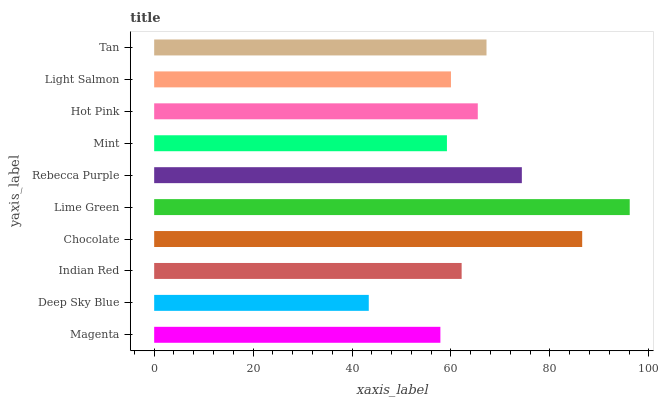Is Deep Sky Blue the minimum?
Answer yes or no. Yes. Is Lime Green the maximum?
Answer yes or no. Yes. Is Indian Red the minimum?
Answer yes or no. No. Is Indian Red the maximum?
Answer yes or no. No. Is Indian Red greater than Deep Sky Blue?
Answer yes or no. Yes. Is Deep Sky Blue less than Indian Red?
Answer yes or no. Yes. Is Deep Sky Blue greater than Indian Red?
Answer yes or no. No. Is Indian Red less than Deep Sky Blue?
Answer yes or no. No. Is Hot Pink the high median?
Answer yes or no. Yes. Is Indian Red the low median?
Answer yes or no. Yes. Is Chocolate the high median?
Answer yes or no. No. Is Light Salmon the low median?
Answer yes or no. No. 